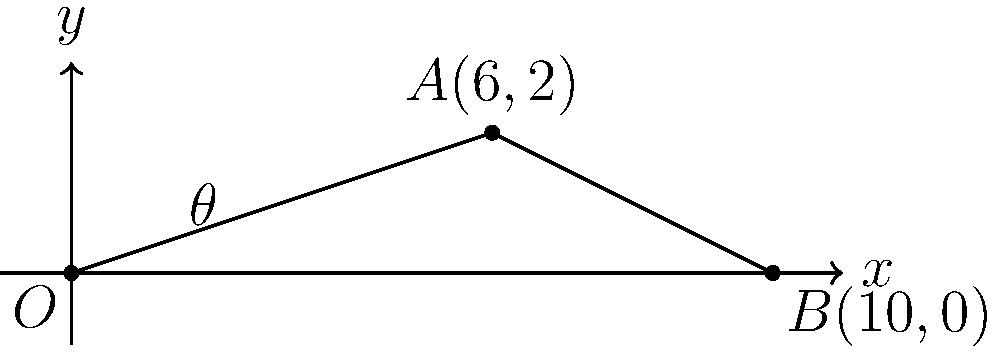In a curling match, a stone is released from point $O$ and travels along the line $OA$. If it continues on this path, it will reach point $B$. Given the coordinates $A(6,2)$ and $B(10,0)$, calculate the angle $\theta$ (in degrees) between the stone's trajectory and the horizontal ice surface. Round your answer to the nearest degree. To find the angle $\theta$, we can use the slope of line $OA$ and the arctangent function. Let's solve this step-by-step:

1) First, calculate the slope of line $OA$:
   $m = \frac{y_2 - y_1}{x_2 - x_1} = \frac{2 - 0}{6 - 0} = \frac{2}{6} = \frac{1}{3}$

2) The slope $m$ is equal to $\tan(\theta)$:
   $\tan(\theta) = \frac{1}{3}$

3) To find $\theta$, we need to use the inverse tangent (arctangent) function:
   $\theta = \arctan(\frac{1}{3})$

4) Calculate this value:
   $\theta \approx 0.3217$ radians

5) Convert radians to degrees:
   $\theta \approx 0.3217 \times \frac{180^{\circ}}{\pi} \approx 18.43^{\circ}$

6) Rounding to the nearest degree:
   $\theta \approx 18^{\circ}$

Therefore, the angle between the stone's trajectory and the horizontal ice surface is approximately 18°.
Answer: $18^{\circ}$ 